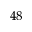Convert formula to latex. <formula><loc_0><loc_0><loc_500><loc_500>^ { 4 8 }</formula> 